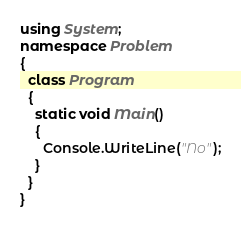<code> <loc_0><loc_0><loc_500><loc_500><_C#_>using System;
namespace Problem
{
  class Program
  {
    static void Main()
    {
      Console.WriteLine("No");
    }
  }
}
    </code> 